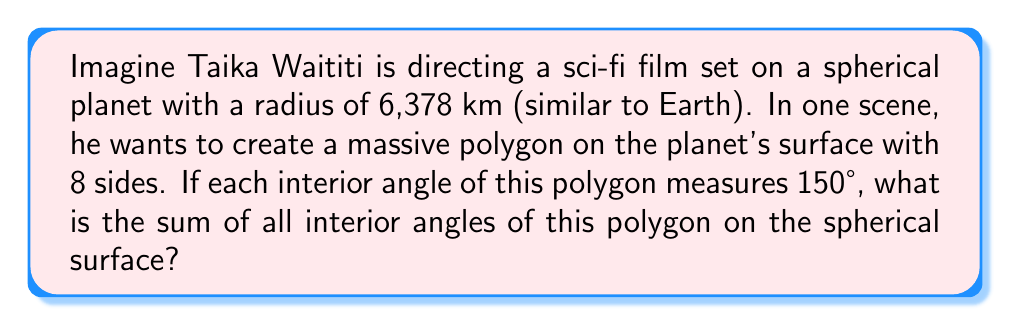Could you help me with this problem? Let's approach this step-by-step:

1) In Euclidean geometry, the sum of interior angles of an n-sided polygon is given by $(n-2) \times 180°$. However, on a spherical surface, this formula doesn't apply.

2) On a sphere, the sum of interior angles of a polygon exceeds the Euclidean sum by an amount proportional to the area of the polygon. This excess is called the spherical excess (E).

3) The formula for the sum of interior angles on a sphere is:

   $S = (n-2) \times 180° + E$

   Where $S$ is the sum of interior angles, $n$ is the number of sides, and $E$ is the spherical excess in degrees.

4) We're given that there are 8 sides and each interior angle measures 150°. So:

   $S = 8 \times 150° = 1200°$

5) Now we can find the spherical excess:

   $1200° = (8-2) \times 180° + E$
   $1200° = 1080° + E$
   $E = 120°$

6) The spherical excess in radians is equal to the area of the polygon divided by the square of the radius:

   $E \text{ (in radians)} = \frac{A}{R^2}$

   Where $A$ is the area of the polygon and $R$ is the radius of the sphere.

7) Converting our excess to radians:

   $120° \times \frac{\pi}{180°} = \frac{2\pi}{3}$ radians

8) Therefore, the area of our polygon is:

   $A = ER^2 = \frac{2\pi}{3} \times 6378^2 \approx 85,540,746 \text{ km}^2$

This area is about 16.8% of the total surface area of the sphere, which checks out as a reasonable size for a large polygon on a planetary surface.
Answer: $1200°$ 